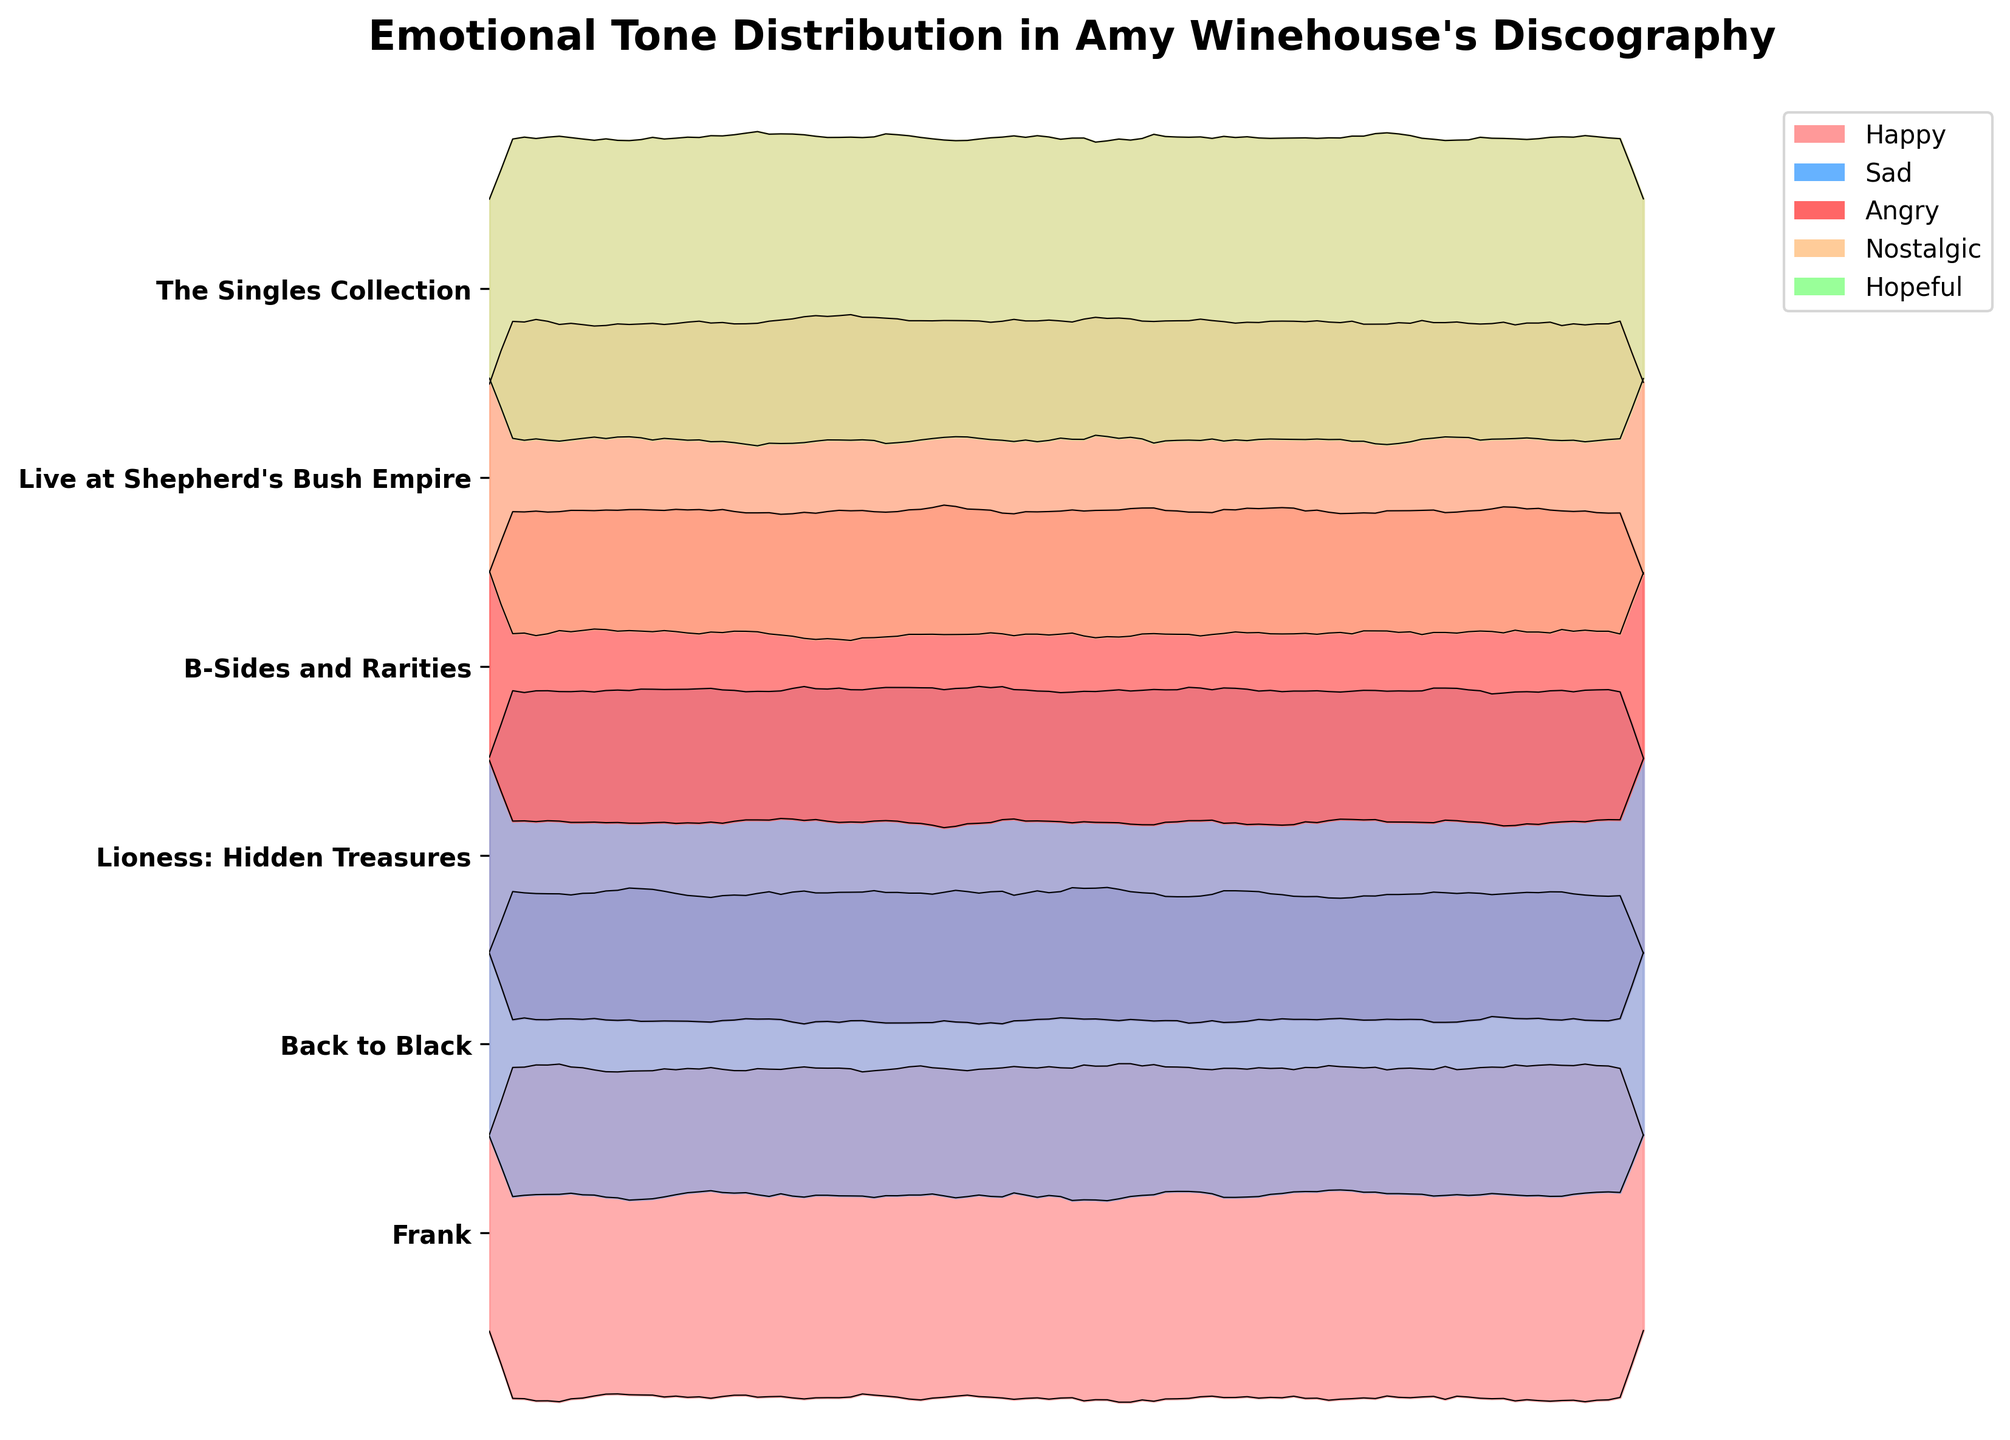What is the title of the plot? The title is located at the top of the plot, providing an overview of what the plot represents. The title is "Emotional Tone Distribution in Amy Winehouse's Discography."
Answer: Emotional Tone Distribution in Amy Winehouse's Discography Which album has the highest proportion of 'Happy' tone? To find the album with the highest proportion of the 'Happy' tone, compare the 'Happy' values for all albums. Live at Shepherd's Bush Empire has the highest value of 0.30.
Answer: Live at Shepherd's Bush Empire What is the emotional tone with the largest proportion in the album 'Back to Black'? Look at the data row for 'Back to Black' and identify the highest value among the emotional tones. 'Sad' has the highest proportion of 0.45.
Answer: Sad How do the 'Sad' proportions compare between 'Frank' and 'Lioness: Hidden Treasures'? Check the 'Sad' proportions for both albums. 'Frank' has 0.35 while 'Lioness: Hidden Treasures' has 0.30. 0.35 is higher than 0.30.
Answer: Frank has a higher 'Sad' proportion Which album has the most balanced (least varied) emotional tone proportions? For each album, observe how close the proportions are to each other. 'B-Sides and Rarities' has relatively balanced proportions: 0.25, 0.25, 0.20, 0.20, 0.10.
Answer: B-Sides and Rarities In the album 'Lioness: Hidden Treasures,' how much higher is the 'Nostalgic' proportion compared to the 'Angry' proportion? Compare the values for 'Nostalgic' (0.25) and 'Angry' (0.15) and find the difference. 0.25 - 0.15 = 0.10.
Answer: 0.10 What is the most common emotional tone across all albums? Identify the emotional tone that appears most frequently with the highest proportion across the different albums. The tone 'Sad' has the highest value in most albums.
Answer: Sad How does the 'Hopeful' proportion in 'Back to Black' compare to that in 'Live at Shepherd's Bush Empire'? 'Back to Black' has 0.05 and 'Live at Shepherd's Bush Empire' has 0.10. Compare the two values: 0.05 is less than 0.10.
Answer: Lower in 'Back to Black' What is the combined proportion of 'Happy' and 'Angry' tones in 'Frank'? Sum the values of 'Happy' (0.15) and 'Angry' (0.20) for 'Frank': 0.15 + 0.20 = 0.35.
Answer: 0.35 Which album shows the highest 'Nostalgic' tone proportion? Compare the 'Nostalgic' proportions across all albums. 'Lioness: Hidden Treasures' and 'Live at Shepherd's Bush Empire' both have the highest 'Nostalgic' proportion of 0.25.
Answer: Lioness: Hidden Treasures; Live at Shepherd's Bush Empire 